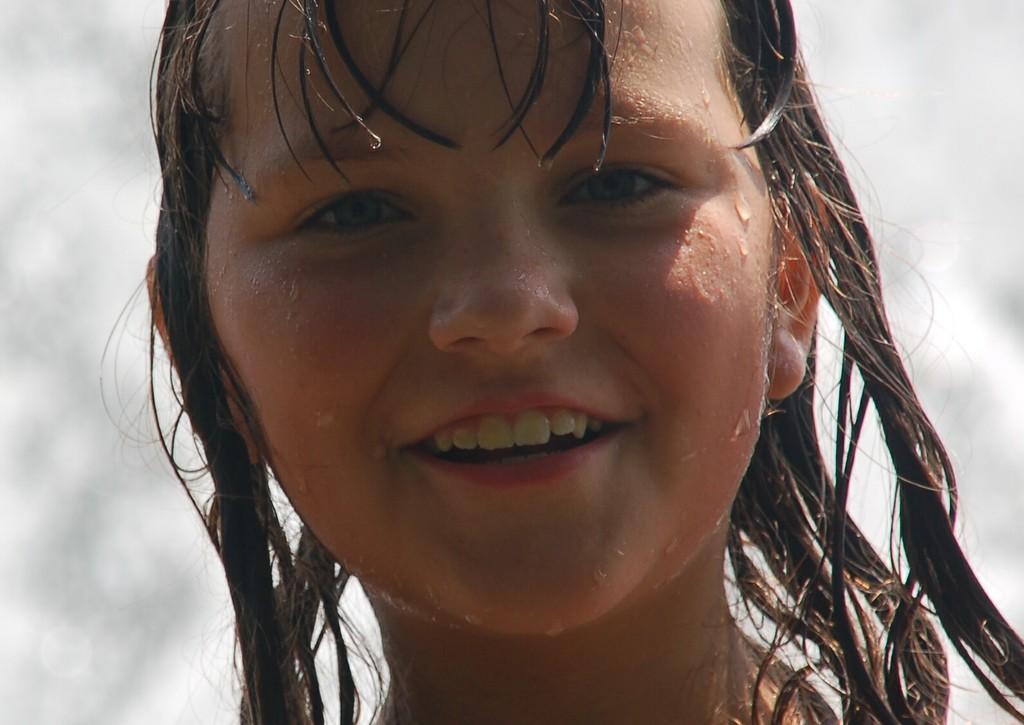Describe this image in one or two sentences. In this picture I can see a girl's face in front and I see that she is smiling and I see water on her face and on her hair. I see that it is white and grey color in the background. 